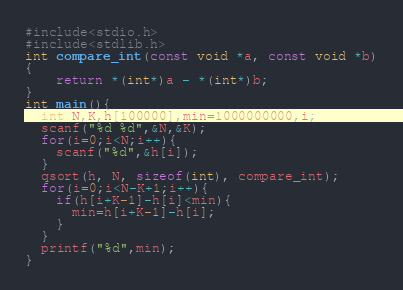<code> <loc_0><loc_0><loc_500><loc_500><_C_>#include<stdio.h>
#include<stdlib.h>
int compare_int(const void *a, const void *b)
{
    return *(int*)a - *(int*)b;
}
int main(){
  int N,K,h[100000],min=1000000000,i;
  scanf("%d %d",&N,&K);
  for(i=0;i<N;i++){
    scanf("%d",&h[i]);
  }
  qsort(h, N, sizeof(int), compare_int);
  for(i=0;i<N-K+1;i++){
    if(h[i+K-1]-h[i]<min){
      min=h[i+K-1]-h[i];
    }
  }
  printf("%d",min);
}
</code> 